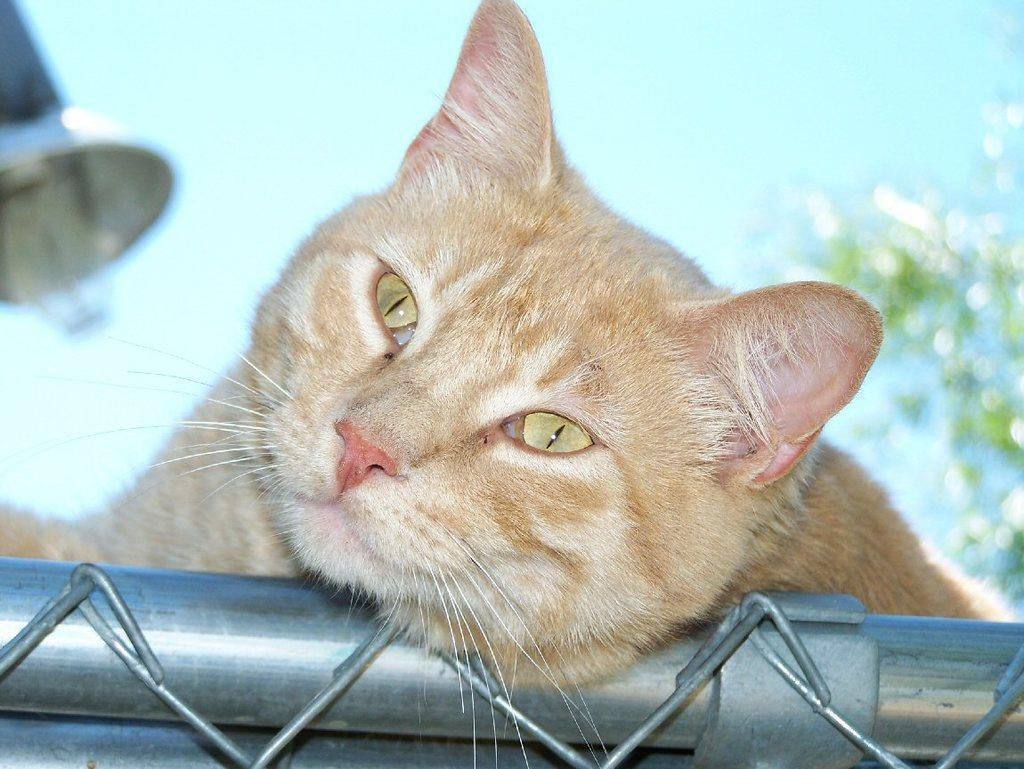What type of animal can be seen in the image? There is a cat in the image. What object is present in the image that might be used for support or leverage? There is a rod in the image. What material is used for the objects in the image? There are metal objects in the image. How would you describe the background of the image? The background of the image is blurry. What chess piece is the cat holding in the image? There is no chess piece present in the image, and the cat is not holding anything. How old is the baby in the image? There is no baby present in the image. 